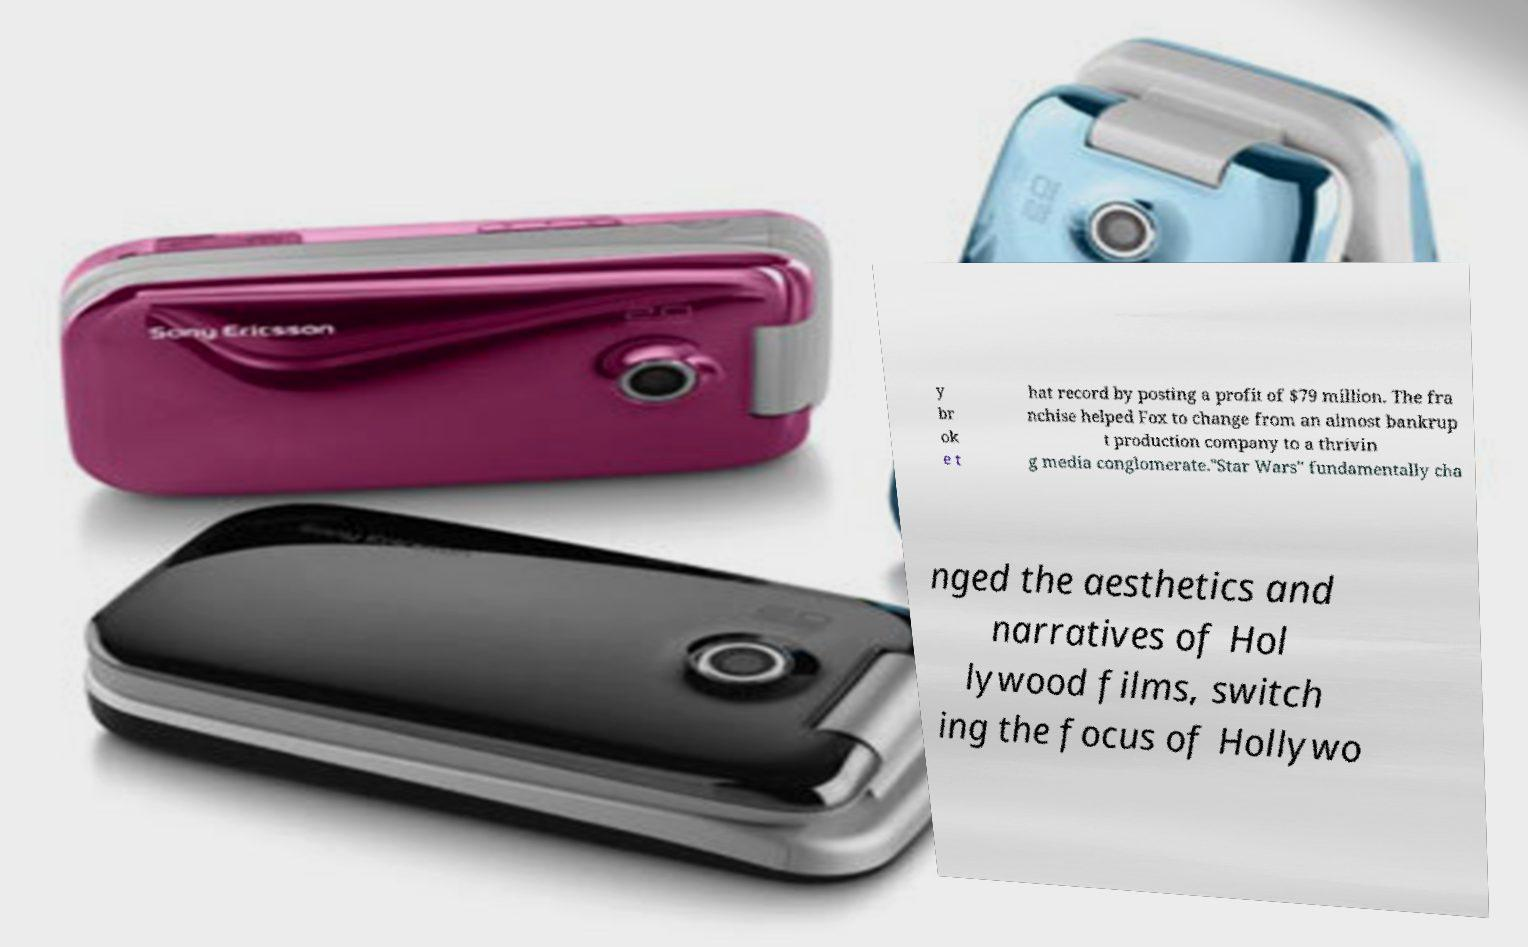Could you assist in decoding the text presented in this image and type it out clearly? y br ok e t hat record by posting a profit of $79 million. The fra nchise helped Fox to change from an almost bankrup t production company to a thrivin g media conglomerate."Star Wars" fundamentally cha nged the aesthetics and narratives of Hol lywood films, switch ing the focus of Hollywo 